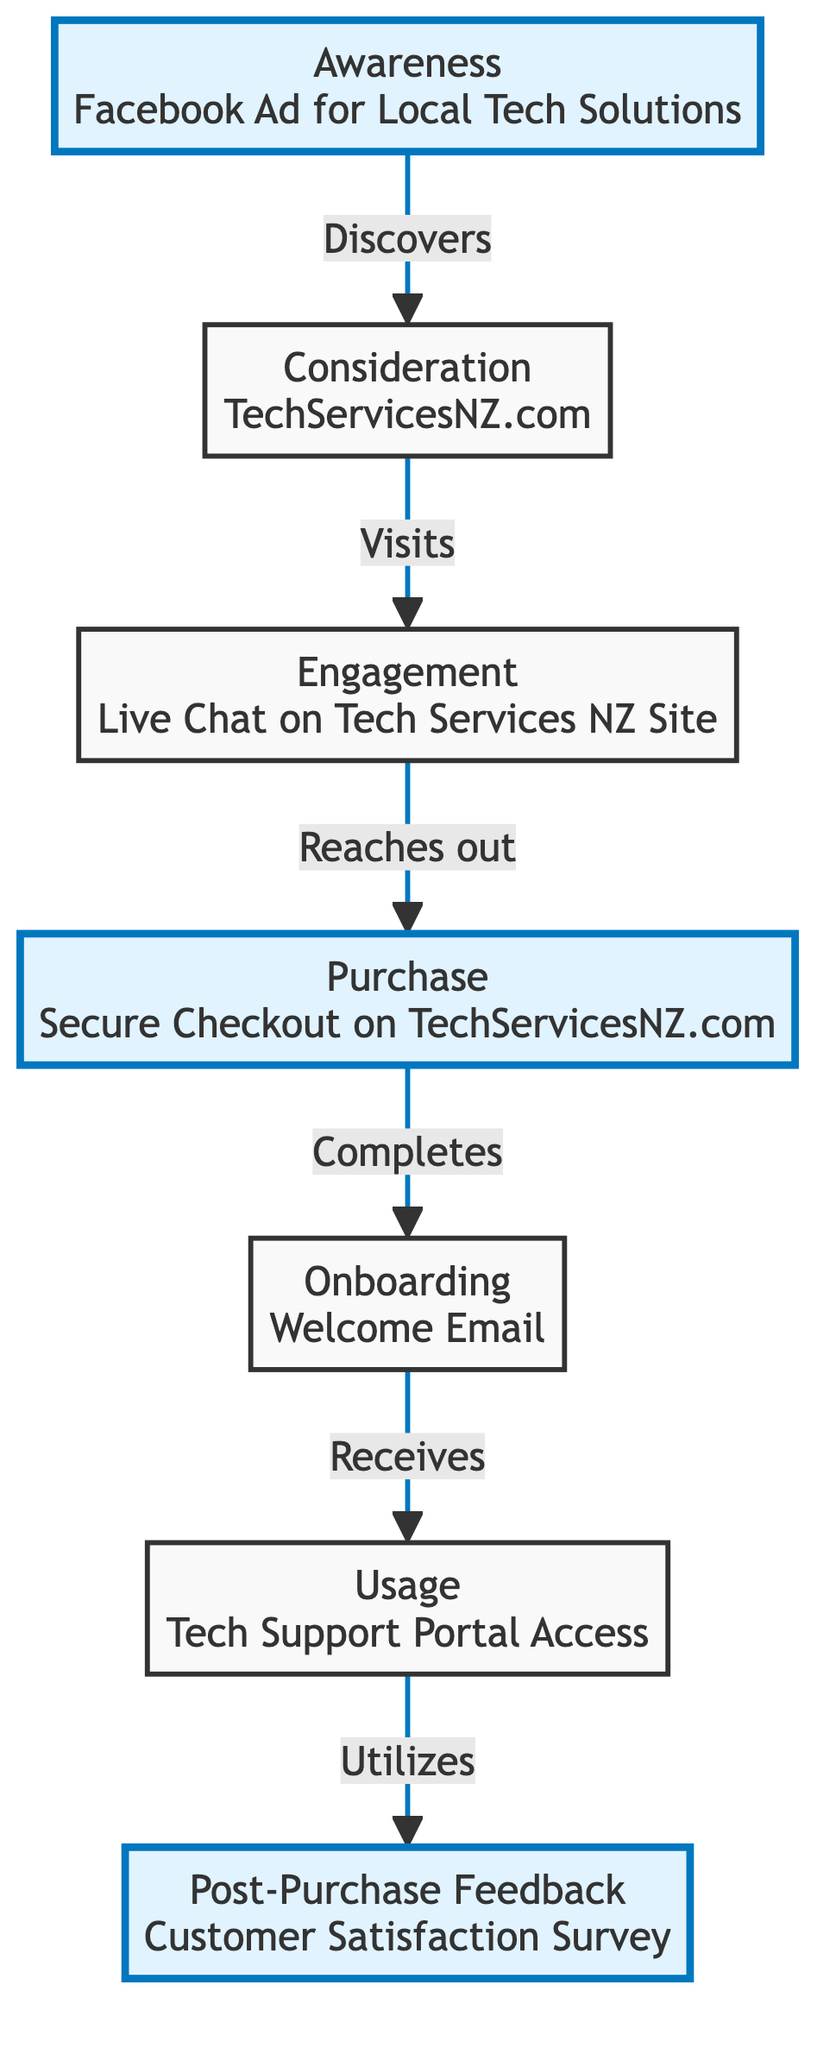What is the first step in the customer journey? The first step is "Awareness," which involves the customer discovering the tech service. This can be seen as the starting point of the flow chart.
Answer: Awareness How many steps are present in the customer journey? By counting the individual nodes listed in the diagram, we find there are a total of seven steps from Awareness to Post-Purchase Feedback.
Answer: Seven What website does the customer visit during the consideration phase? The consideration step indicates the customer visits "TechServicesNZ.com" to learn more about the service offerings and pricing. This is a direct point of reference in the diagram.
Answer: TechServicesNZ.com What action does the customer take in the engagement phase? In the engagement phase, the customer "reaches out" via live chat, as indicated in the flow chart to obtain personalized answers.
Answer: Reaches out What does the customer receive after the purchase step? After the purchase step, the customer receives an "onboarding email with setup instructions," as shown in the diagram. This connects directly to the following step.
Answer: Onboarding email What links the onboarding step to the usage step? The onboarding step links to the usage step by the action described: the customer "receives" the onboarding email, which guides them to utilize the service effectively.
Answer: Receives What type of feedback does the customer provide in the last step? The last step involves the customer providing "post-purchase feedback" through a satisfaction survey, as represented in the diagram.
Answer: Satisfaction survey Which step involves a secure checkout? The purchase step specifically mentions that the customer completes the purchase through "Secure Checkout on TechServicesNZ.com." This part of the diagram clearly labels the checkout action.
Answer: Secure Checkout What is the relationship between the engagement and purchase steps? The relationship is that the customer engages by reaching out through live chat and this interaction leads them to the purchase step; hence, they are directly connected through the flow by the action of reaching out.
Answer: Reaches out 